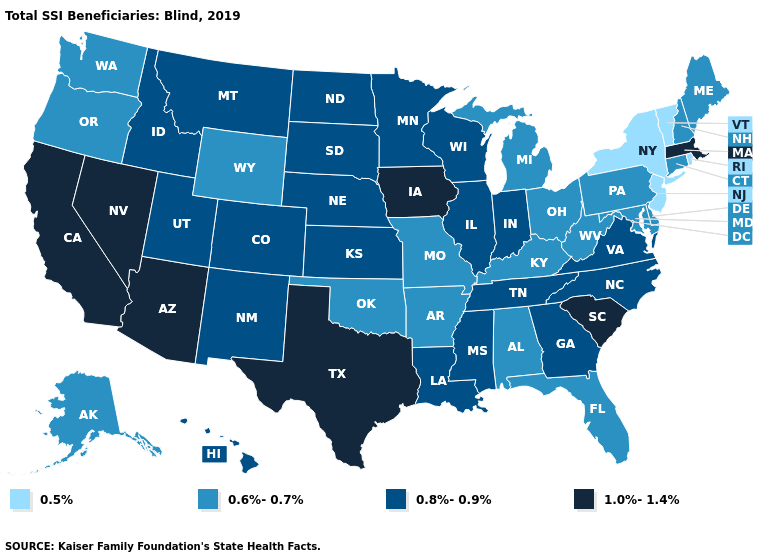Which states have the lowest value in the West?
Be succinct. Alaska, Oregon, Washington, Wyoming. Among the states that border Colorado , which have the lowest value?
Write a very short answer. Oklahoma, Wyoming. Does the map have missing data?
Keep it brief. No. Which states have the lowest value in the USA?
Answer briefly. New Jersey, New York, Rhode Island, Vermont. What is the value of South Dakota?
Write a very short answer. 0.8%-0.9%. Which states have the lowest value in the USA?
Answer briefly. New Jersey, New York, Rhode Island, Vermont. What is the value of West Virginia?
Give a very brief answer. 0.6%-0.7%. What is the lowest value in states that border Iowa?
Be succinct. 0.6%-0.7%. What is the value of West Virginia?
Concise answer only. 0.6%-0.7%. Does Kentucky have a higher value than North Dakota?
Short answer required. No. What is the highest value in states that border Florida?
Keep it brief. 0.8%-0.9%. Name the states that have a value in the range 0.8%-0.9%?
Answer briefly. Colorado, Georgia, Hawaii, Idaho, Illinois, Indiana, Kansas, Louisiana, Minnesota, Mississippi, Montana, Nebraska, New Mexico, North Carolina, North Dakota, South Dakota, Tennessee, Utah, Virginia, Wisconsin. Name the states that have a value in the range 1.0%-1.4%?
Be succinct. Arizona, California, Iowa, Massachusetts, Nevada, South Carolina, Texas. Which states have the highest value in the USA?
Concise answer only. Arizona, California, Iowa, Massachusetts, Nevada, South Carolina, Texas. What is the value of Alaska?
Short answer required. 0.6%-0.7%. 